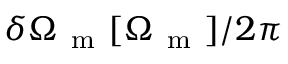Convert formula to latex. <formula><loc_0><loc_0><loc_500><loc_500>\delta \Omega _ { m } [ \Omega _ { m } ] / 2 \pi</formula> 